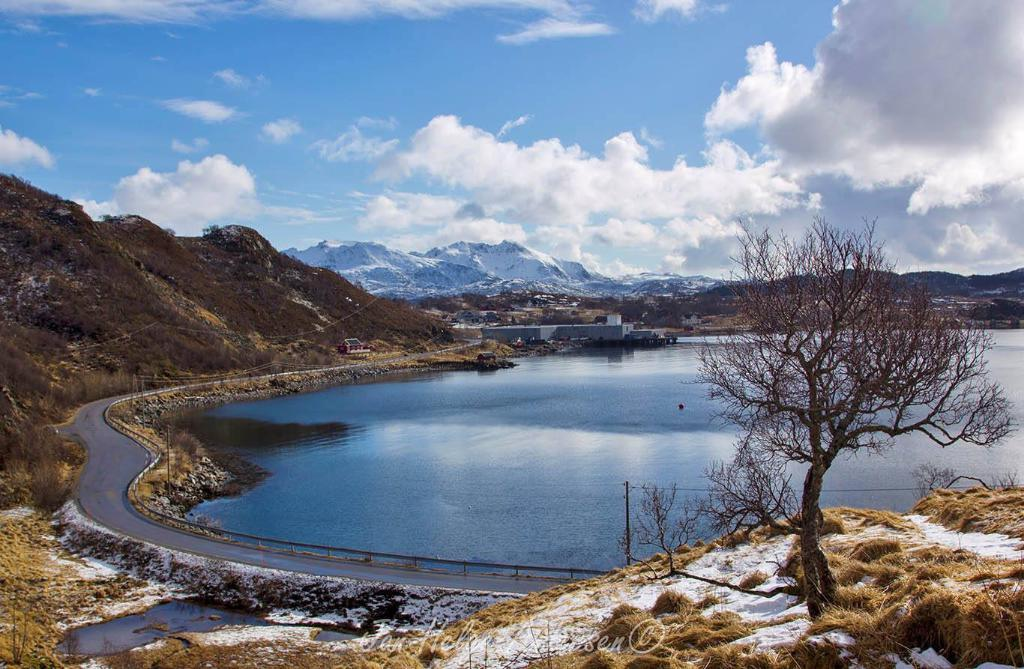What can be seen in the sky in the image? The sky with clouds is visible in the image. What type of natural features are present in the image? There are hills, mountains, trees, and a river visible in the image. What man-made structures can be seen in the image? There are buildings, a road, a fence, electric poles, and electric cables present in the image. What type of vegetation is present in the image? Grass is present in the image, along with trees. Can you tell me how many rats are sitting on the electric cables in the image? There are no rats present in the image; only electric cables are visible. What type of attention is the river receiving in the image? The river is not receiving any specific attention in the image; it is simply one of the natural features present. 